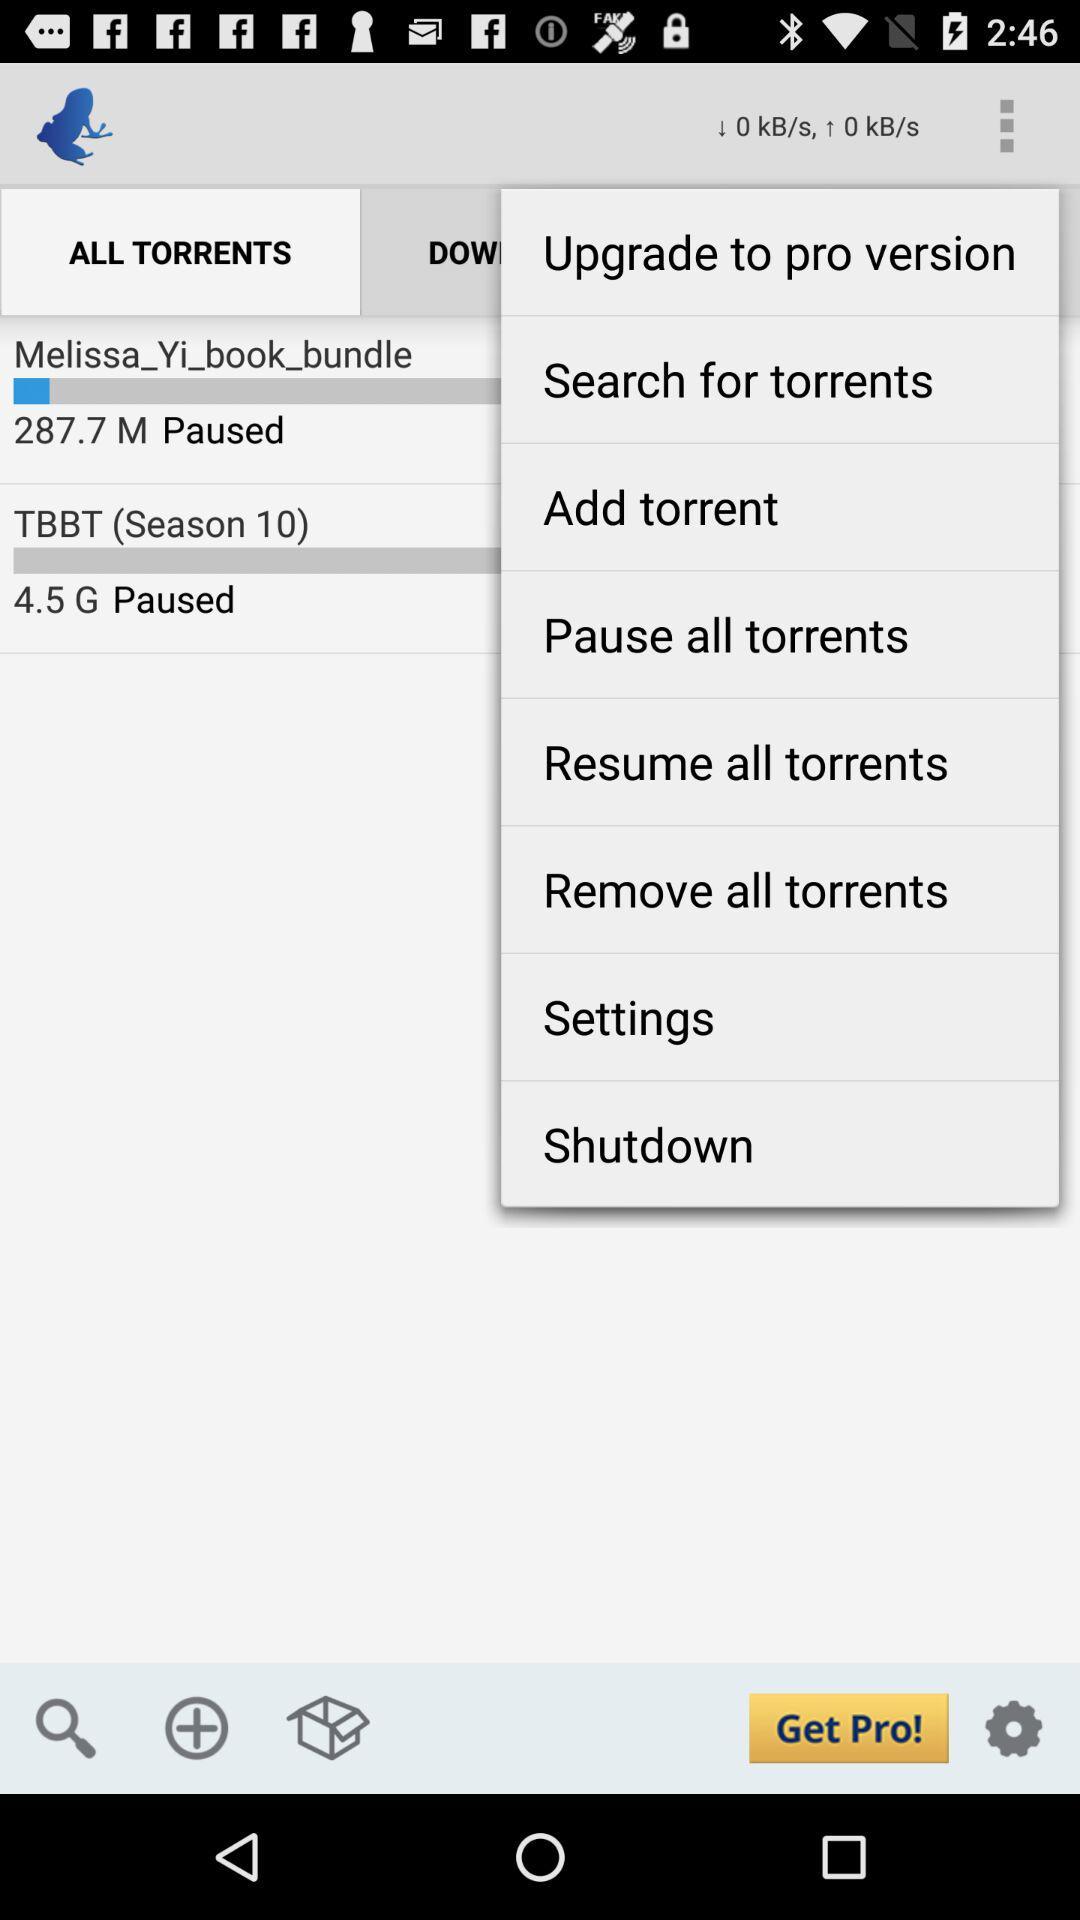What is the size of "Melissa_Yi_book_ bundle"? The size of "Melissa_Yi_book_ bundle" is 287.7 M. 